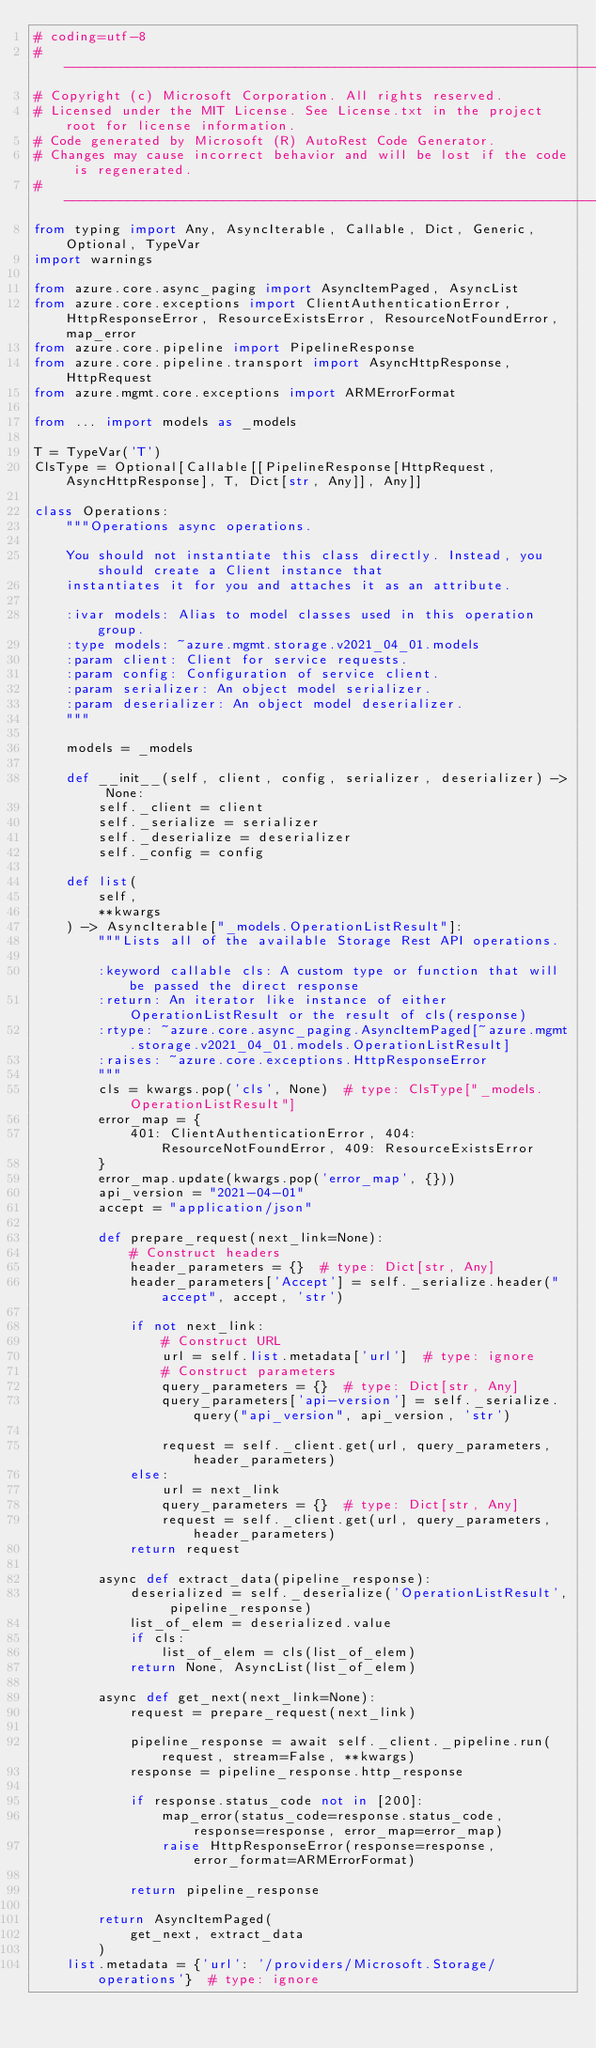<code> <loc_0><loc_0><loc_500><loc_500><_Python_># coding=utf-8
# --------------------------------------------------------------------------
# Copyright (c) Microsoft Corporation. All rights reserved.
# Licensed under the MIT License. See License.txt in the project root for license information.
# Code generated by Microsoft (R) AutoRest Code Generator.
# Changes may cause incorrect behavior and will be lost if the code is regenerated.
# --------------------------------------------------------------------------
from typing import Any, AsyncIterable, Callable, Dict, Generic, Optional, TypeVar
import warnings

from azure.core.async_paging import AsyncItemPaged, AsyncList
from azure.core.exceptions import ClientAuthenticationError, HttpResponseError, ResourceExistsError, ResourceNotFoundError, map_error
from azure.core.pipeline import PipelineResponse
from azure.core.pipeline.transport import AsyncHttpResponse, HttpRequest
from azure.mgmt.core.exceptions import ARMErrorFormat

from ... import models as _models

T = TypeVar('T')
ClsType = Optional[Callable[[PipelineResponse[HttpRequest, AsyncHttpResponse], T, Dict[str, Any]], Any]]

class Operations:
    """Operations async operations.

    You should not instantiate this class directly. Instead, you should create a Client instance that
    instantiates it for you and attaches it as an attribute.

    :ivar models: Alias to model classes used in this operation group.
    :type models: ~azure.mgmt.storage.v2021_04_01.models
    :param client: Client for service requests.
    :param config: Configuration of service client.
    :param serializer: An object model serializer.
    :param deserializer: An object model deserializer.
    """

    models = _models

    def __init__(self, client, config, serializer, deserializer) -> None:
        self._client = client
        self._serialize = serializer
        self._deserialize = deserializer
        self._config = config

    def list(
        self,
        **kwargs
    ) -> AsyncIterable["_models.OperationListResult"]:
        """Lists all of the available Storage Rest API operations.

        :keyword callable cls: A custom type or function that will be passed the direct response
        :return: An iterator like instance of either OperationListResult or the result of cls(response)
        :rtype: ~azure.core.async_paging.AsyncItemPaged[~azure.mgmt.storage.v2021_04_01.models.OperationListResult]
        :raises: ~azure.core.exceptions.HttpResponseError
        """
        cls = kwargs.pop('cls', None)  # type: ClsType["_models.OperationListResult"]
        error_map = {
            401: ClientAuthenticationError, 404: ResourceNotFoundError, 409: ResourceExistsError
        }
        error_map.update(kwargs.pop('error_map', {}))
        api_version = "2021-04-01"
        accept = "application/json"

        def prepare_request(next_link=None):
            # Construct headers
            header_parameters = {}  # type: Dict[str, Any]
            header_parameters['Accept'] = self._serialize.header("accept", accept, 'str')

            if not next_link:
                # Construct URL
                url = self.list.metadata['url']  # type: ignore
                # Construct parameters
                query_parameters = {}  # type: Dict[str, Any]
                query_parameters['api-version'] = self._serialize.query("api_version", api_version, 'str')

                request = self._client.get(url, query_parameters, header_parameters)
            else:
                url = next_link
                query_parameters = {}  # type: Dict[str, Any]
                request = self._client.get(url, query_parameters, header_parameters)
            return request

        async def extract_data(pipeline_response):
            deserialized = self._deserialize('OperationListResult', pipeline_response)
            list_of_elem = deserialized.value
            if cls:
                list_of_elem = cls(list_of_elem)
            return None, AsyncList(list_of_elem)

        async def get_next(next_link=None):
            request = prepare_request(next_link)

            pipeline_response = await self._client._pipeline.run(request, stream=False, **kwargs)
            response = pipeline_response.http_response

            if response.status_code not in [200]:
                map_error(status_code=response.status_code, response=response, error_map=error_map)
                raise HttpResponseError(response=response, error_format=ARMErrorFormat)

            return pipeline_response

        return AsyncItemPaged(
            get_next, extract_data
        )
    list.metadata = {'url': '/providers/Microsoft.Storage/operations'}  # type: ignore
</code> 